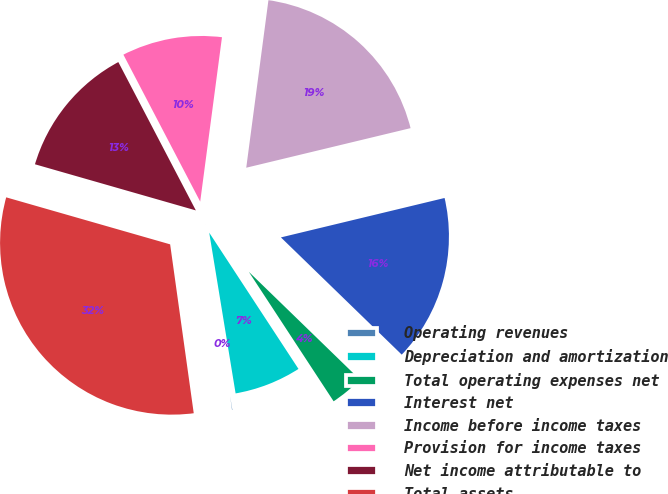<chart> <loc_0><loc_0><loc_500><loc_500><pie_chart><fcel>Operating revenues<fcel>Depreciation and amortization<fcel>Total operating expenses net<fcel>Interest net<fcel>Income before income taxes<fcel>Provision for income taxes<fcel>Net income attributable to<fcel>Total assets<nl><fcel>0.38%<fcel>6.64%<fcel>3.51%<fcel>16.02%<fcel>19.14%<fcel>9.76%<fcel>12.89%<fcel>31.65%<nl></chart> 